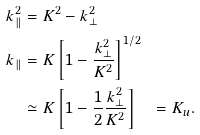Convert formula to latex. <formula><loc_0><loc_0><loc_500><loc_500>k _ { \| } ^ { 2 } & = K ^ { 2 } - k _ { \perp } ^ { 2 } \\ k _ { \| } & = K \left [ 1 - \frac { k _ { \perp } ^ { 2 } } { K ^ { 2 } } \right ] ^ { 1 / 2 } \\ & \simeq K \left [ 1 - \frac { 1 } { 2 } \frac { k _ { \perp } ^ { 2 } } { K ^ { 2 } } \right ] \quad = K _ { u } .</formula> 